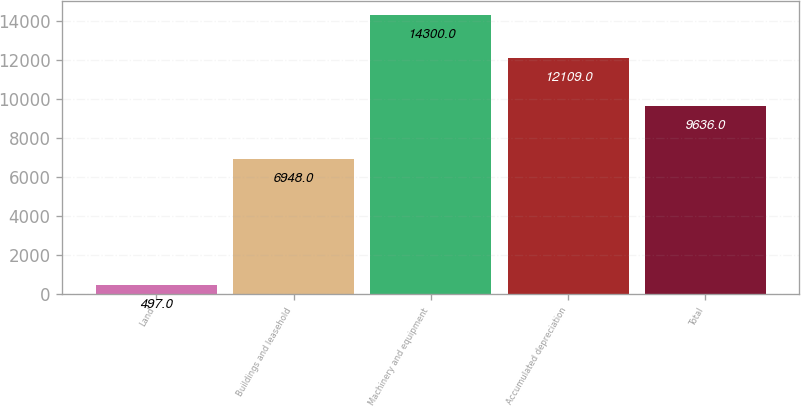<chart> <loc_0><loc_0><loc_500><loc_500><bar_chart><fcel>Land<fcel>Buildings and leasehold<fcel>Machinery and equipment<fcel>Accumulated depreciation<fcel>Total<nl><fcel>497<fcel>6948<fcel>14300<fcel>12109<fcel>9636<nl></chart> 